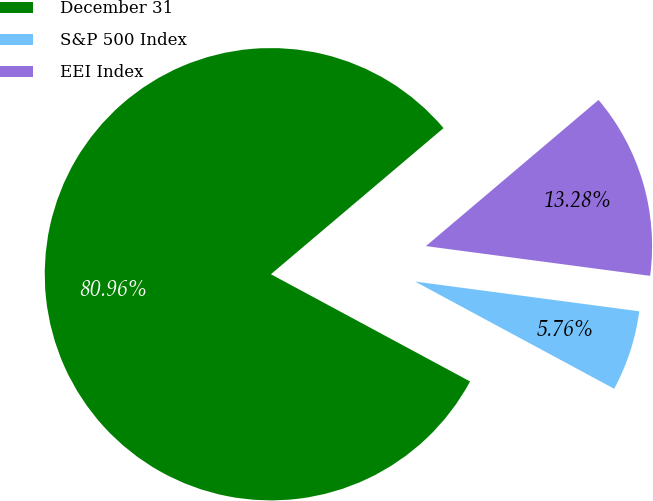Convert chart. <chart><loc_0><loc_0><loc_500><loc_500><pie_chart><fcel>December 31<fcel>S&P 500 Index<fcel>EEI Index<nl><fcel>80.95%<fcel>5.76%<fcel>13.28%<nl></chart> 